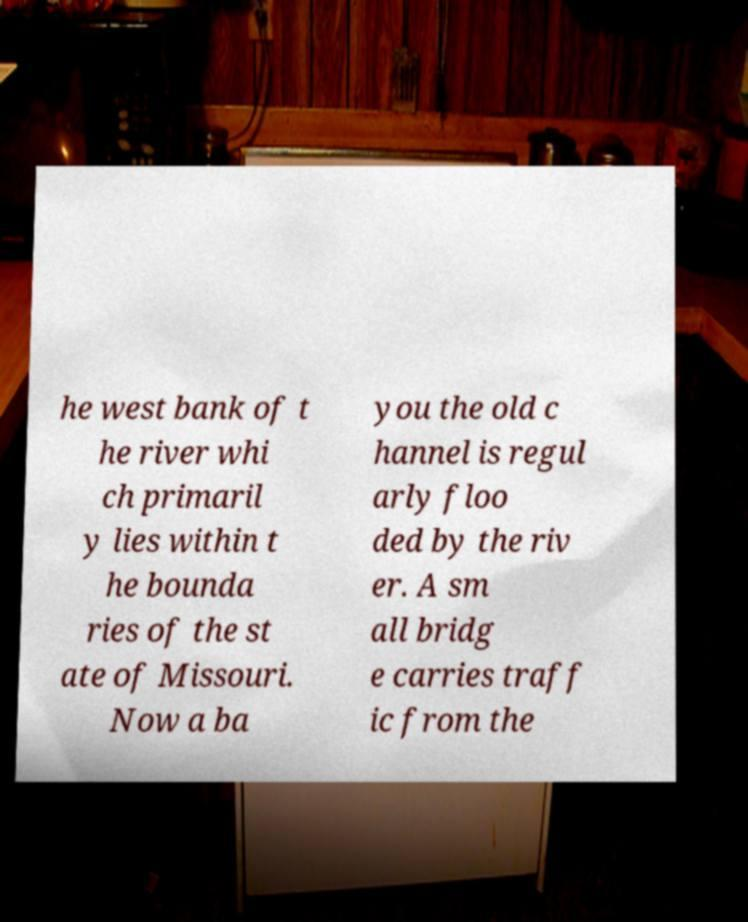What messages or text are displayed in this image? I need them in a readable, typed format. he west bank of t he river whi ch primaril y lies within t he bounda ries of the st ate of Missouri. Now a ba you the old c hannel is regul arly floo ded by the riv er. A sm all bridg e carries traff ic from the 